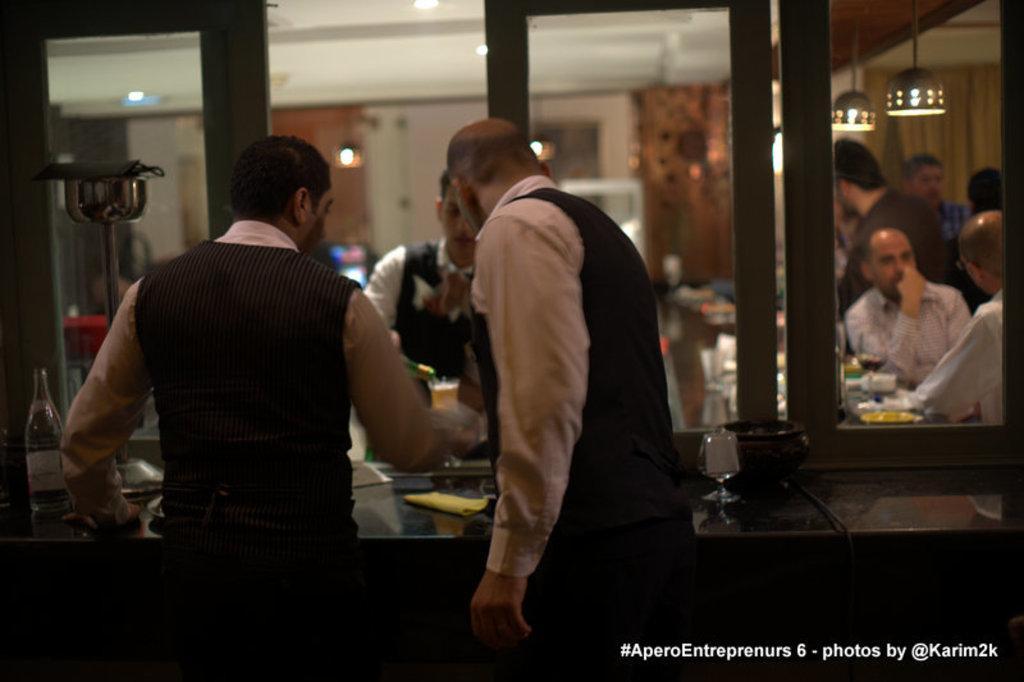How would you summarize this image in a sentence or two? In this picture we can observe two men standing in front of a desk on which we can observe a glass and a bottle. There is a window. We can observe some peoples sitting and standing on the right side. in the background there is a wall. 